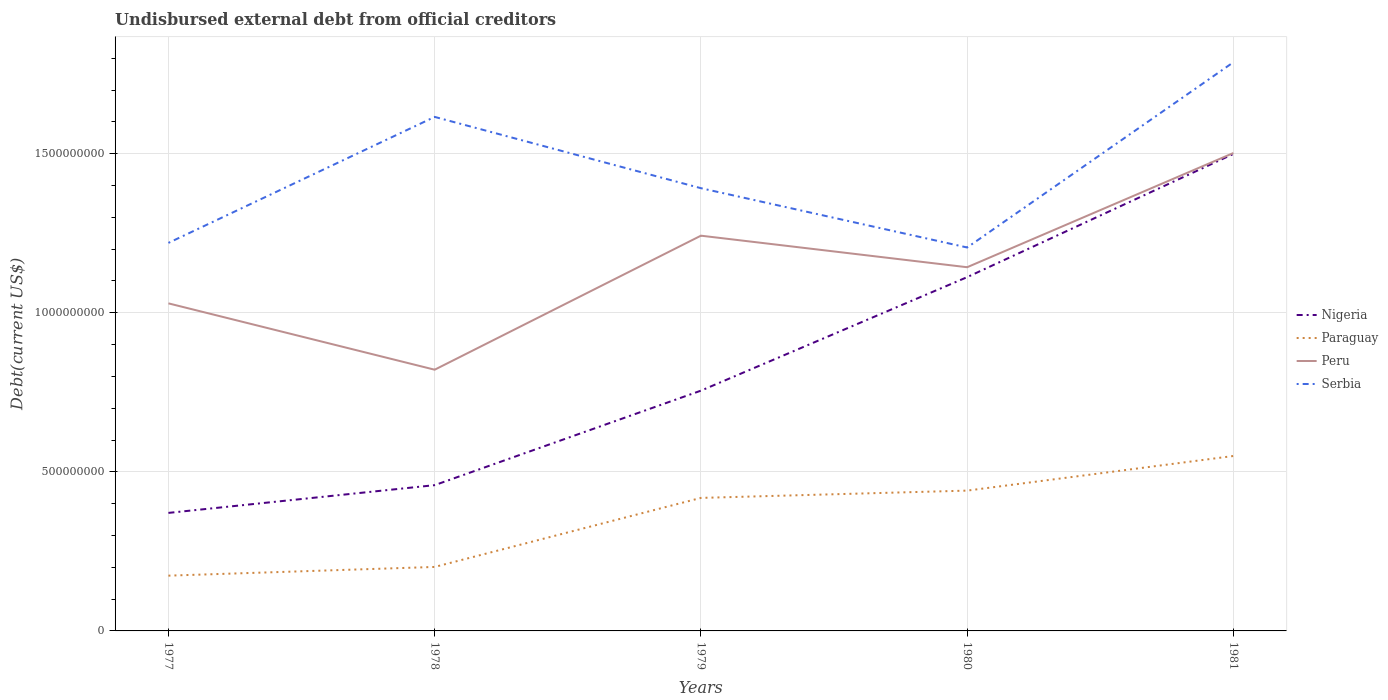How many different coloured lines are there?
Keep it short and to the point. 4. Across all years, what is the maximum total debt in Serbia?
Your answer should be very brief. 1.21e+09. In which year was the total debt in Paraguay maximum?
Ensure brevity in your answer.  1977. What is the total total debt in Nigeria in the graph?
Keep it short and to the point. -8.72e+07. What is the difference between the highest and the second highest total debt in Paraguay?
Give a very brief answer. 3.76e+08. How many lines are there?
Ensure brevity in your answer.  4. How many years are there in the graph?
Give a very brief answer. 5. Are the values on the major ticks of Y-axis written in scientific E-notation?
Provide a succinct answer. No. Does the graph contain grids?
Your answer should be compact. Yes. How are the legend labels stacked?
Give a very brief answer. Vertical. What is the title of the graph?
Make the answer very short. Undisbursed external debt from official creditors. What is the label or title of the Y-axis?
Give a very brief answer. Debt(current US$). What is the Debt(current US$) of Nigeria in 1977?
Provide a short and direct response. 3.71e+08. What is the Debt(current US$) of Paraguay in 1977?
Keep it short and to the point. 1.74e+08. What is the Debt(current US$) in Peru in 1977?
Offer a very short reply. 1.03e+09. What is the Debt(current US$) of Serbia in 1977?
Ensure brevity in your answer.  1.22e+09. What is the Debt(current US$) in Nigeria in 1978?
Your response must be concise. 4.58e+08. What is the Debt(current US$) of Paraguay in 1978?
Keep it short and to the point. 2.01e+08. What is the Debt(current US$) of Peru in 1978?
Your response must be concise. 8.21e+08. What is the Debt(current US$) in Serbia in 1978?
Offer a very short reply. 1.62e+09. What is the Debt(current US$) in Nigeria in 1979?
Your answer should be compact. 7.55e+08. What is the Debt(current US$) in Paraguay in 1979?
Provide a succinct answer. 4.18e+08. What is the Debt(current US$) of Peru in 1979?
Make the answer very short. 1.24e+09. What is the Debt(current US$) in Serbia in 1979?
Offer a very short reply. 1.39e+09. What is the Debt(current US$) of Nigeria in 1980?
Make the answer very short. 1.11e+09. What is the Debt(current US$) in Paraguay in 1980?
Provide a succinct answer. 4.41e+08. What is the Debt(current US$) in Peru in 1980?
Keep it short and to the point. 1.14e+09. What is the Debt(current US$) of Serbia in 1980?
Your answer should be very brief. 1.21e+09. What is the Debt(current US$) in Nigeria in 1981?
Your response must be concise. 1.50e+09. What is the Debt(current US$) in Paraguay in 1981?
Your answer should be compact. 5.50e+08. What is the Debt(current US$) in Peru in 1981?
Your response must be concise. 1.50e+09. What is the Debt(current US$) in Serbia in 1981?
Provide a short and direct response. 1.79e+09. Across all years, what is the maximum Debt(current US$) of Nigeria?
Make the answer very short. 1.50e+09. Across all years, what is the maximum Debt(current US$) of Paraguay?
Provide a succinct answer. 5.50e+08. Across all years, what is the maximum Debt(current US$) of Peru?
Give a very brief answer. 1.50e+09. Across all years, what is the maximum Debt(current US$) in Serbia?
Your answer should be very brief. 1.79e+09. Across all years, what is the minimum Debt(current US$) of Nigeria?
Give a very brief answer. 3.71e+08. Across all years, what is the minimum Debt(current US$) in Paraguay?
Your answer should be compact. 1.74e+08. Across all years, what is the minimum Debt(current US$) of Peru?
Provide a succinct answer. 8.21e+08. Across all years, what is the minimum Debt(current US$) in Serbia?
Your answer should be compact. 1.21e+09. What is the total Debt(current US$) of Nigeria in the graph?
Keep it short and to the point. 4.20e+09. What is the total Debt(current US$) in Paraguay in the graph?
Give a very brief answer. 1.78e+09. What is the total Debt(current US$) in Peru in the graph?
Provide a short and direct response. 5.74e+09. What is the total Debt(current US$) in Serbia in the graph?
Your answer should be very brief. 7.22e+09. What is the difference between the Debt(current US$) of Nigeria in 1977 and that in 1978?
Provide a succinct answer. -8.72e+07. What is the difference between the Debt(current US$) in Paraguay in 1977 and that in 1978?
Provide a succinct answer. -2.74e+07. What is the difference between the Debt(current US$) in Peru in 1977 and that in 1978?
Offer a terse response. 2.09e+08. What is the difference between the Debt(current US$) of Serbia in 1977 and that in 1978?
Provide a short and direct response. -3.96e+08. What is the difference between the Debt(current US$) of Nigeria in 1977 and that in 1979?
Keep it short and to the point. -3.84e+08. What is the difference between the Debt(current US$) of Paraguay in 1977 and that in 1979?
Ensure brevity in your answer.  -2.44e+08. What is the difference between the Debt(current US$) of Peru in 1977 and that in 1979?
Your response must be concise. -2.13e+08. What is the difference between the Debt(current US$) of Serbia in 1977 and that in 1979?
Offer a very short reply. -1.72e+08. What is the difference between the Debt(current US$) of Nigeria in 1977 and that in 1980?
Offer a terse response. -7.41e+08. What is the difference between the Debt(current US$) of Paraguay in 1977 and that in 1980?
Provide a short and direct response. -2.67e+08. What is the difference between the Debt(current US$) of Peru in 1977 and that in 1980?
Your response must be concise. -1.14e+08. What is the difference between the Debt(current US$) of Serbia in 1977 and that in 1980?
Your answer should be very brief. 1.44e+07. What is the difference between the Debt(current US$) in Nigeria in 1977 and that in 1981?
Provide a succinct answer. -1.13e+09. What is the difference between the Debt(current US$) in Paraguay in 1977 and that in 1981?
Your answer should be compact. -3.76e+08. What is the difference between the Debt(current US$) of Peru in 1977 and that in 1981?
Keep it short and to the point. -4.73e+08. What is the difference between the Debt(current US$) of Serbia in 1977 and that in 1981?
Provide a short and direct response. -5.68e+08. What is the difference between the Debt(current US$) in Nigeria in 1978 and that in 1979?
Offer a terse response. -2.97e+08. What is the difference between the Debt(current US$) of Paraguay in 1978 and that in 1979?
Make the answer very short. -2.17e+08. What is the difference between the Debt(current US$) of Peru in 1978 and that in 1979?
Offer a terse response. -4.21e+08. What is the difference between the Debt(current US$) of Serbia in 1978 and that in 1979?
Give a very brief answer. 2.24e+08. What is the difference between the Debt(current US$) of Nigeria in 1978 and that in 1980?
Give a very brief answer. -6.54e+08. What is the difference between the Debt(current US$) of Paraguay in 1978 and that in 1980?
Offer a very short reply. -2.40e+08. What is the difference between the Debt(current US$) in Peru in 1978 and that in 1980?
Your answer should be very brief. -3.22e+08. What is the difference between the Debt(current US$) in Serbia in 1978 and that in 1980?
Your answer should be very brief. 4.10e+08. What is the difference between the Debt(current US$) of Nigeria in 1978 and that in 1981?
Make the answer very short. -1.04e+09. What is the difference between the Debt(current US$) of Paraguay in 1978 and that in 1981?
Offer a terse response. -3.49e+08. What is the difference between the Debt(current US$) of Peru in 1978 and that in 1981?
Keep it short and to the point. -6.81e+08. What is the difference between the Debt(current US$) of Serbia in 1978 and that in 1981?
Your answer should be very brief. -1.72e+08. What is the difference between the Debt(current US$) in Nigeria in 1979 and that in 1980?
Your response must be concise. -3.57e+08. What is the difference between the Debt(current US$) in Paraguay in 1979 and that in 1980?
Offer a terse response. -2.29e+07. What is the difference between the Debt(current US$) of Peru in 1979 and that in 1980?
Provide a short and direct response. 9.91e+07. What is the difference between the Debt(current US$) in Serbia in 1979 and that in 1980?
Make the answer very short. 1.86e+08. What is the difference between the Debt(current US$) in Nigeria in 1979 and that in 1981?
Give a very brief answer. -7.44e+08. What is the difference between the Debt(current US$) of Paraguay in 1979 and that in 1981?
Your answer should be very brief. -1.32e+08. What is the difference between the Debt(current US$) in Peru in 1979 and that in 1981?
Your answer should be very brief. -2.60e+08. What is the difference between the Debt(current US$) of Serbia in 1979 and that in 1981?
Your response must be concise. -3.96e+08. What is the difference between the Debt(current US$) in Nigeria in 1980 and that in 1981?
Your response must be concise. -3.87e+08. What is the difference between the Debt(current US$) in Paraguay in 1980 and that in 1981?
Offer a very short reply. -1.09e+08. What is the difference between the Debt(current US$) in Peru in 1980 and that in 1981?
Give a very brief answer. -3.59e+08. What is the difference between the Debt(current US$) of Serbia in 1980 and that in 1981?
Your answer should be compact. -5.82e+08. What is the difference between the Debt(current US$) of Nigeria in 1977 and the Debt(current US$) of Paraguay in 1978?
Make the answer very short. 1.70e+08. What is the difference between the Debt(current US$) in Nigeria in 1977 and the Debt(current US$) in Peru in 1978?
Provide a succinct answer. -4.50e+08. What is the difference between the Debt(current US$) in Nigeria in 1977 and the Debt(current US$) in Serbia in 1978?
Offer a very short reply. -1.24e+09. What is the difference between the Debt(current US$) in Paraguay in 1977 and the Debt(current US$) in Peru in 1978?
Keep it short and to the point. -6.47e+08. What is the difference between the Debt(current US$) in Paraguay in 1977 and the Debt(current US$) in Serbia in 1978?
Offer a very short reply. -1.44e+09. What is the difference between the Debt(current US$) in Peru in 1977 and the Debt(current US$) in Serbia in 1978?
Keep it short and to the point. -5.86e+08. What is the difference between the Debt(current US$) in Nigeria in 1977 and the Debt(current US$) in Paraguay in 1979?
Provide a succinct answer. -4.71e+07. What is the difference between the Debt(current US$) of Nigeria in 1977 and the Debt(current US$) of Peru in 1979?
Provide a succinct answer. -8.71e+08. What is the difference between the Debt(current US$) in Nigeria in 1977 and the Debt(current US$) in Serbia in 1979?
Your answer should be compact. -1.02e+09. What is the difference between the Debt(current US$) in Paraguay in 1977 and the Debt(current US$) in Peru in 1979?
Ensure brevity in your answer.  -1.07e+09. What is the difference between the Debt(current US$) of Paraguay in 1977 and the Debt(current US$) of Serbia in 1979?
Give a very brief answer. -1.22e+09. What is the difference between the Debt(current US$) in Peru in 1977 and the Debt(current US$) in Serbia in 1979?
Your answer should be very brief. -3.62e+08. What is the difference between the Debt(current US$) in Nigeria in 1977 and the Debt(current US$) in Paraguay in 1980?
Offer a terse response. -7.01e+07. What is the difference between the Debt(current US$) of Nigeria in 1977 and the Debt(current US$) of Peru in 1980?
Offer a terse response. -7.72e+08. What is the difference between the Debt(current US$) of Nigeria in 1977 and the Debt(current US$) of Serbia in 1980?
Your response must be concise. -8.34e+08. What is the difference between the Debt(current US$) of Paraguay in 1977 and the Debt(current US$) of Peru in 1980?
Ensure brevity in your answer.  -9.69e+08. What is the difference between the Debt(current US$) in Paraguay in 1977 and the Debt(current US$) in Serbia in 1980?
Your answer should be very brief. -1.03e+09. What is the difference between the Debt(current US$) in Peru in 1977 and the Debt(current US$) in Serbia in 1980?
Give a very brief answer. -1.76e+08. What is the difference between the Debt(current US$) in Nigeria in 1977 and the Debt(current US$) in Paraguay in 1981?
Provide a short and direct response. -1.79e+08. What is the difference between the Debt(current US$) in Nigeria in 1977 and the Debt(current US$) in Peru in 1981?
Offer a very short reply. -1.13e+09. What is the difference between the Debt(current US$) of Nigeria in 1977 and the Debt(current US$) of Serbia in 1981?
Provide a succinct answer. -1.42e+09. What is the difference between the Debt(current US$) of Paraguay in 1977 and the Debt(current US$) of Peru in 1981?
Offer a terse response. -1.33e+09. What is the difference between the Debt(current US$) in Paraguay in 1977 and the Debt(current US$) in Serbia in 1981?
Offer a terse response. -1.61e+09. What is the difference between the Debt(current US$) of Peru in 1977 and the Debt(current US$) of Serbia in 1981?
Your answer should be compact. -7.58e+08. What is the difference between the Debt(current US$) of Nigeria in 1978 and the Debt(current US$) of Paraguay in 1979?
Ensure brevity in your answer.  4.01e+07. What is the difference between the Debt(current US$) in Nigeria in 1978 and the Debt(current US$) in Peru in 1979?
Give a very brief answer. -7.84e+08. What is the difference between the Debt(current US$) in Nigeria in 1978 and the Debt(current US$) in Serbia in 1979?
Offer a very short reply. -9.33e+08. What is the difference between the Debt(current US$) of Paraguay in 1978 and the Debt(current US$) of Peru in 1979?
Offer a terse response. -1.04e+09. What is the difference between the Debt(current US$) in Paraguay in 1978 and the Debt(current US$) in Serbia in 1979?
Your answer should be very brief. -1.19e+09. What is the difference between the Debt(current US$) in Peru in 1978 and the Debt(current US$) in Serbia in 1979?
Offer a very short reply. -5.71e+08. What is the difference between the Debt(current US$) in Nigeria in 1978 and the Debt(current US$) in Paraguay in 1980?
Your response must be concise. 1.71e+07. What is the difference between the Debt(current US$) in Nigeria in 1978 and the Debt(current US$) in Peru in 1980?
Keep it short and to the point. -6.85e+08. What is the difference between the Debt(current US$) of Nigeria in 1978 and the Debt(current US$) of Serbia in 1980?
Your response must be concise. -7.47e+08. What is the difference between the Debt(current US$) in Paraguay in 1978 and the Debt(current US$) in Peru in 1980?
Offer a terse response. -9.42e+08. What is the difference between the Debt(current US$) in Paraguay in 1978 and the Debt(current US$) in Serbia in 1980?
Make the answer very short. -1.00e+09. What is the difference between the Debt(current US$) in Peru in 1978 and the Debt(current US$) in Serbia in 1980?
Your response must be concise. -3.84e+08. What is the difference between the Debt(current US$) in Nigeria in 1978 and the Debt(current US$) in Paraguay in 1981?
Your answer should be very brief. -9.16e+07. What is the difference between the Debt(current US$) of Nigeria in 1978 and the Debt(current US$) of Peru in 1981?
Ensure brevity in your answer.  -1.04e+09. What is the difference between the Debt(current US$) in Nigeria in 1978 and the Debt(current US$) in Serbia in 1981?
Your answer should be very brief. -1.33e+09. What is the difference between the Debt(current US$) of Paraguay in 1978 and the Debt(current US$) of Peru in 1981?
Give a very brief answer. -1.30e+09. What is the difference between the Debt(current US$) in Paraguay in 1978 and the Debt(current US$) in Serbia in 1981?
Keep it short and to the point. -1.59e+09. What is the difference between the Debt(current US$) of Peru in 1978 and the Debt(current US$) of Serbia in 1981?
Ensure brevity in your answer.  -9.66e+08. What is the difference between the Debt(current US$) in Nigeria in 1979 and the Debt(current US$) in Paraguay in 1980?
Your answer should be very brief. 3.14e+08. What is the difference between the Debt(current US$) in Nigeria in 1979 and the Debt(current US$) in Peru in 1980?
Give a very brief answer. -3.88e+08. What is the difference between the Debt(current US$) of Nigeria in 1979 and the Debt(current US$) of Serbia in 1980?
Give a very brief answer. -4.50e+08. What is the difference between the Debt(current US$) of Paraguay in 1979 and the Debt(current US$) of Peru in 1980?
Offer a terse response. -7.25e+08. What is the difference between the Debt(current US$) in Paraguay in 1979 and the Debt(current US$) in Serbia in 1980?
Your answer should be very brief. -7.87e+08. What is the difference between the Debt(current US$) in Peru in 1979 and the Debt(current US$) in Serbia in 1980?
Keep it short and to the point. 3.71e+07. What is the difference between the Debt(current US$) in Nigeria in 1979 and the Debt(current US$) in Paraguay in 1981?
Your answer should be very brief. 2.05e+08. What is the difference between the Debt(current US$) in Nigeria in 1979 and the Debt(current US$) in Peru in 1981?
Provide a short and direct response. -7.47e+08. What is the difference between the Debt(current US$) in Nigeria in 1979 and the Debt(current US$) in Serbia in 1981?
Your answer should be compact. -1.03e+09. What is the difference between the Debt(current US$) in Paraguay in 1979 and the Debt(current US$) in Peru in 1981?
Keep it short and to the point. -1.08e+09. What is the difference between the Debt(current US$) in Paraguay in 1979 and the Debt(current US$) in Serbia in 1981?
Keep it short and to the point. -1.37e+09. What is the difference between the Debt(current US$) of Peru in 1979 and the Debt(current US$) of Serbia in 1981?
Ensure brevity in your answer.  -5.45e+08. What is the difference between the Debt(current US$) of Nigeria in 1980 and the Debt(current US$) of Paraguay in 1981?
Your response must be concise. 5.62e+08. What is the difference between the Debt(current US$) of Nigeria in 1980 and the Debt(current US$) of Peru in 1981?
Your answer should be compact. -3.90e+08. What is the difference between the Debt(current US$) of Nigeria in 1980 and the Debt(current US$) of Serbia in 1981?
Your answer should be very brief. -6.75e+08. What is the difference between the Debt(current US$) in Paraguay in 1980 and the Debt(current US$) in Peru in 1981?
Provide a succinct answer. -1.06e+09. What is the difference between the Debt(current US$) in Paraguay in 1980 and the Debt(current US$) in Serbia in 1981?
Your response must be concise. -1.35e+09. What is the difference between the Debt(current US$) of Peru in 1980 and the Debt(current US$) of Serbia in 1981?
Make the answer very short. -6.44e+08. What is the average Debt(current US$) in Nigeria per year?
Keep it short and to the point. 8.39e+08. What is the average Debt(current US$) of Paraguay per year?
Your response must be concise. 3.57e+08. What is the average Debt(current US$) in Peru per year?
Your answer should be compact. 1.15e+09. What is the average Debt(current US$) in Serbia per year?
Provide a succinct answer. 1.44e+09. In the year 1977, what is the difference between the Debt(current US$) of Nigeria and Debt(current US$) of Paraguay?
Ensure brevity in your answer.  1.97e+08. In the year 1977, what is the difference between the Debt(current US$) of Nigeria and Debt(current US$) of Peru?
Keep it short and to the point. -6.59e+08. In the year 1977, what is the difference between the Debt(current US$) of Nigeria and Debt(current US$) of Serbia?
Your response must be concise. -8.49e+08. In the year 1977, what is the difference between the Debt(current US$) in Paraguay and Debt(current US$) in Peru?
Your response must be concise. -8.56e+08. In the year 1977, what is the difference between the Debt(current US$) in Paraguay and Debt(current US$) in Serbia?
Provide a short and direct response. -1.05e+09. In the year 1977, what is the difference between the Debt(current US$) in Peru and Debt(current US$) in Serbia?
Ensure brevity in your answer.  -1.90e+08. In the year 1978, what is the difference between the Debt(current US$) of Nigeria and Debt(current US$) of Paraguay?
Keep it short and to the point. 2.57e+08. In the year 1978, what is the difference between the Debt(current US$) of Nigeria and Debt(current US$) of Peru?
Make the answer very short. -3.63e+08. In the year 1978, what is the difference between the Debt(current US$) in Nigeria and Debt(current US$) in Serbia?
Your answer should be compact. -1.16e+09. In the year 1978, what is the difference between the Debt(current US$) of Paraguay and Debt(current US$) of Peru?
Provide a short and direct response. -6.20e+08. In the year 1978, what is the difference between the Debt(current US$) of Paraguay and Debt(current US$) of Serbia?
Offer a terse response. -1.41e+09. In the year 1978, what is the difference between the Debt(current US$) in Peru and Debt(current US$) in Serbia?
Provide a short and direct response. -7.95e+08. In the year 1979, what is the difference between the Debt(current US$) of Nigeria and Debt(current US$) of Paraguay?
Your answer should be compact. 3.37e+08. In the year 1979, what is the difference between the Debt(current US$) of Nigeria and Debt(current US$) of Peru?
Your response must be concise. -4.87e+08. In the year 1979, what is the difference between the Debt(current US$) in Nigeria and Debt(current US$) in Serbia?
Your response must be concise. -6.36e+08. In the year 1979, what is the difference between the Debt(current US$) of Paraguay and Debt(current US$) of Peru?
Your response must be concise. -8.24e+08. In the year 1979, what is the difference between the Debt(current US$) of Paraguay and Debt(current US$) of Serbia?
Give a very brief answer. -9.73e+08. In the year 1979, what is the difference between the Debt(current US$) in Peru and Debt(current US$) in Serbia?
Give a very brief answer. -1.49e+08. In the year 1980, what is the difference between the Debt(current US$) in Nigeria and Debt(current US$) in Paraguay?
Provide a short and direct response. 6.71e+08. In the year 1980, what is the difference between the Debt(current US$) in Nigeria and Debt(current US$) in Peru?
Ensure brevity in your answer.  -3.12e+07. In the year 1980, what is the difference between the Debt(current US$) of Nigeria and Debt(current US$) of Serbia?
Your answer should be very brief. -9.32e+07. In the year 1980, what is the difference between the Debt(current US$) in Paraguay and Debt(current US$) in Peru?
Your answer should be compact. -7.02e+08. In the year 1980, what is the difference between the Debt(current US$) of Paraguay and Debt(current US$) of Serbia?
Provide a succinct answer. -7.64e+08. In the year 1980, what is the difference between the Debt(current US$) of Peru and Debt(current US$) of Serbia?
Offer a terse response. -6.20e+07. In the year 1981, what is the difference between the Debt(current US$) of Nigeria and Debt(current US$) of Paraguay?
Ensure brevity in your answer.  9.49e+08. In the year 1981, what is the difference between the Debt(current US$) of Nigeria and Debt(current US$) of Peru?
Your answer should be compact. -2.88e+06. In the year 1981, what is the difference between the Debt(current US$) in Nigeria and Debt(current US$) in Serbia?
Ensure brevity in your answer.  -2.88e+08. In the year 1981, what is the difference between the Debt(current US$) in Paraguay and Debt(current US$) in Peru?
Give a very brief answer. -9.52e+08. In the year 1981, what is the difference between the Debt(current US$) in Paraguay and Debt(current US$) in Serbia?
Offer a terse response. -1.24e+09. In the year 1981, what is the difference between the Debt(current US$) in Peru and Debt(current US$) in Serbia?
Make the answer very short. -2.85e+08. What is the ratio of the Debt(current US$) in Nigeria in 1977 to that in 1978?
Keep it short and to the point. 0.81. What is the ratio of the Debt(current US$) in Paraguay in 1977 to that in 1978?
Offer a very short reply. 0.86. What is the ratio of the Debt(current US$) in Peru in 1977 to that in 1978?
Offer a terse response. 1.25. What is the ratio of the Debt(current US$) of Serbia in 1977 to that in 1978?
Offer a very short reply. 0.75. What is the ratio of the Debt(current US$) of Nigeria in 1977 to that in 1979?
Your response must be concise. 0.49. What is the ratio of the Debt(current US$) of Paraguay in 1977 to that in 1979?
Ensure brevity in your answer.  0.42. What is the ratio of the Debt(current US$) of Peru in 1977 to that in 1979?
Offer a terse response. 0.83. What is the ratio of the Debt(current US$) in Serbia in 1977 to that in 1979?
Your answer should be very brief. 0.88. What is the ratio of the Debt(current US$) of Nigeria in 1977 to that in 1980?
Offer a terse response. 0.33. What is the ratio of the Debt(current US$) of Paraguay in 1977 to that in 1980?
Give a very brief answer. 0.39. What is the ratio of the Debt(current US$) in Peru in 1977 to that in 1980?
Ensure brevity in your answer.  0.9. What is the ratio of the Debt(current US$) of Serbia in 1977 to that in 1980?
Ensure brevity in your answer.  1.01. What is the ratio of the Debt(current US$) of Nigeria in 1977 to that in 1981?
Your response must be concise. 0.25. What is the ratio of the Debt(current US$) in Paraguay in 1977 to that in 1981?
Keep it short and to the point. 0.32. What is the ratio of the Debt(current US$) in Peru in 1977 to that in 1981?
Your answer should be very brief. 0.69. What is the ratio of the Debt(current US$) in Serbia in 1977 to that in 1981?
Offer a terse response. 0.68. What is the ratio of the Debt(current US$) in Nigeria in 1978 to that in 1979?
Ensure brevity in your answer.  0.61. What is the ratio of the Debt(current US$) of Paraguay in 1978 to that in 1979?
Your answer should be very brief. 0.48. What is the ratio of the Debt(current US$) of Peru in 1978 to that in 1979?
Ensure brevity in your answer.  0.66. What is the ratio of the Debt(current US$) in Serbia in 1978 to that in 1979?
Provide a succinct answer. 1.16. What is the ratio of the Debt(current US$) of Nigeria in 1978 to that in 1980?
Offer a terse response. 0.41. What is the ratio of the Debt(current US$) in Paraguay in 1978 to that in 1980?
Ensure brevity in your answer.  0.46. What is the ratio of the Debt(current US$) of Peru in 1978 to that in 1980?
Offer a terse response. 0.72. What is the ratio of the Debt(current US$) in Serbia in 1978 to that in 1980?
Keep it short and to the point. 1.34. What is the ratio of the Debt(current US$) in Nigeria in 1978 to that in 1981?
Your answer should be compact. 0.31. What is the ratio of the Debt(current US$) of Paraguay in 1978 to that in 1981?
Your answer should be very brief. 0.37. What is the ratio of the Debt(current US$) of Peru in 1978 to that in 1981?
Ensure brevity in your answer.  0.55. What is the ratio of the Debt(current US$) in Serbia in 1978 to that in 1981?
Your response must be concise. 0.9. What is the ratio of the Debt(current US$) in Nigeria in 1979 to that in 1980?
Make the answer very short. 0.68. What is the ratio of the Debt(current US$) in Paraguay in 1979 to that in 1980?
Your response must be concise. 0.95. What is the ratio of the Debt(current US$) in Peru in 1979 to that in 1980?
Provide a succinct answer. 1.09. What is the ratio of the Debt(current US$) in Serbia in 1979 to that in 1980?
Ensure brevity in your answer.  1.15. What is the ratio of the Debt(current US$) of Nigeria in 1979 to that in 1981?
Keep it short and to the point. 0.5. What is the ratio of the Debt(current US$) in Paraguay in 1979 to that in 1981?
Give a very brief answer. 0.76. What is the ratio of the Debt(current US$) of Peru in 1979 to that in 1981?
Keep it short and to the point. 0.83. What is the ratio of the Debt(current US$) of Serbia in 1979 to that in 1981?
Provide a short and direct response. 0.78. What is the ratio of the Debt(current US$) in Nigeria in 1980 to that in 1981?
Offer a very short reply. 0.74. What is the ratio of the Debt(current US$) of Paraguay in 1980 to that in 1981?
Make the answer very short. 0.8. What is the ratio of the Debt(current US$) in Peru in 1980 to that in 1981?
Offer a terse response. 0.76. What is the ratio of the Debt(current US$) in Serbia in 1980 to that in 1981?
Provide a succinct answer. 0.67. What is the difference between the highest and the second highest Debt(current US$) of Nigeria?
Ensure brevity in your answer.  3.87e+08. What is the difference between the highest and the second highest Debt(current US$) of Paraguay?
Give a very brief answer. 1.09e+08. What is the difference between the highest and the second highest Debt(current US$) in Peru?
Keep it short and to the point. 2.60e+08. What is the difference between the highest and the second highest Debt(current US$) in Serbia?
Offer a very short reply. 1.72e+08. What is the difference between the highest and the lowest Debt(current US$) in Nigeria?
Ensure brevity in your answer.  1.13e+09. What is the difference between the highest and the lowest Debt(current US$) of Paraguay?
Your response must be concise. 3.76e+08. What is the difference between the highest and the lowest Debt(current US$) of Peru?
Keep it short and to the point. 6.81e+08. What is the difference between the highest and the lowest Debt(current US$) in Serbia?
Give a very brief answer. 5.82e+08. 